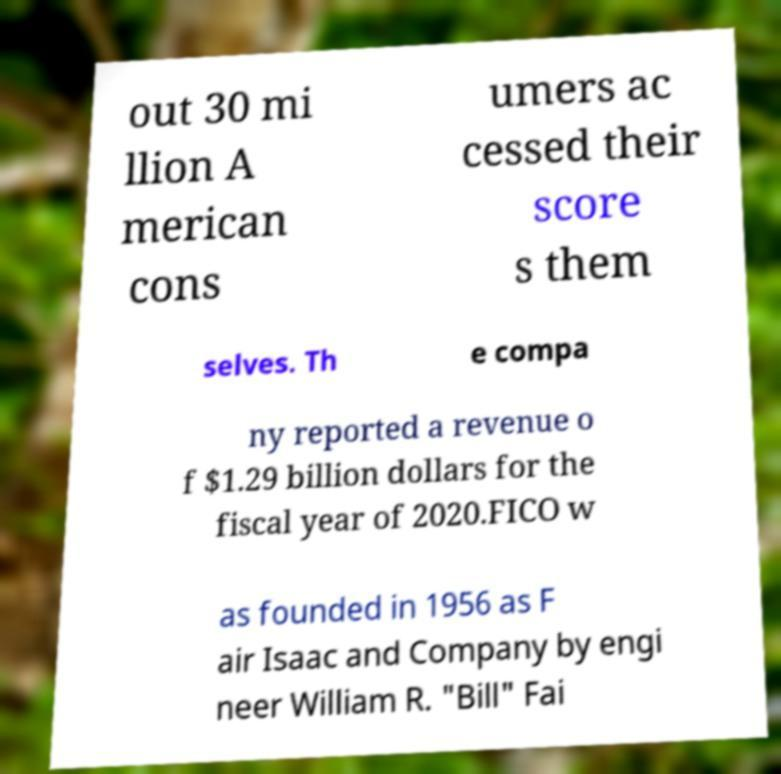Could you assist in decoding the text presented in this image and type it out clearly? out 30 mi llion A merican cons umers ac cessed their score s them selves. Th e compa ny reported a revenue o f $1.29 billion dollars for the fiscal year of 2020.FICO w as founded in 1956 as F air Isaac and Company by engi neer William R. "Bill" Fai 